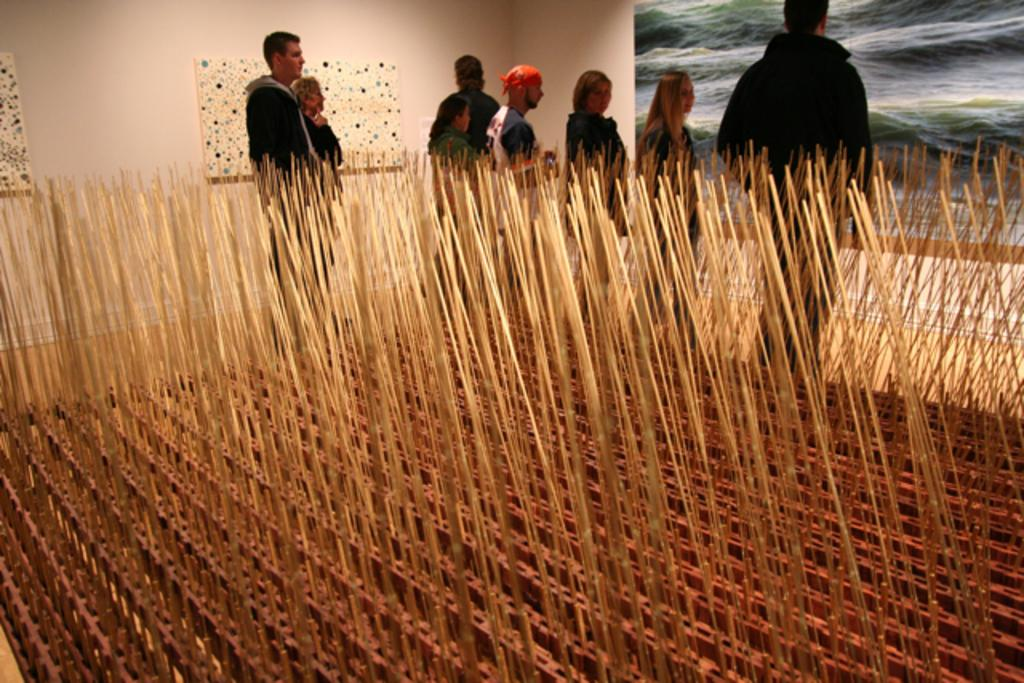Who or what can be seen in the image? There are people in the image. What else is present on the ground in the image? There are objects on the ground in the image. What can be seen in the background of the image? There is a wall visible in the image. What type of objects are present on the wall in the image? There are boards with images in the image. What type of arithmetic problem is being solved by the lawyer in the image? There is no lawyer or arithmetic problem present in the image. 